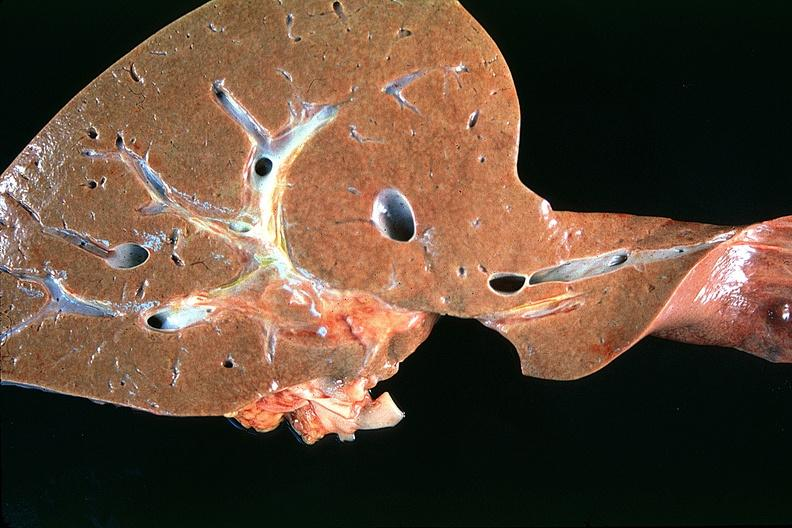what is present?
Answer the question using a single word or phrase. Hepatobiliary 